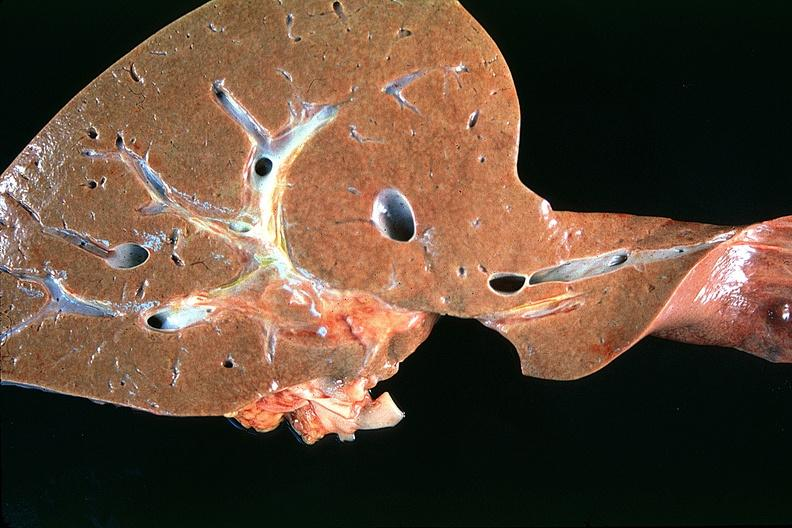what is present?
Answer the question using a single word or phrase. Hepatobiliary 